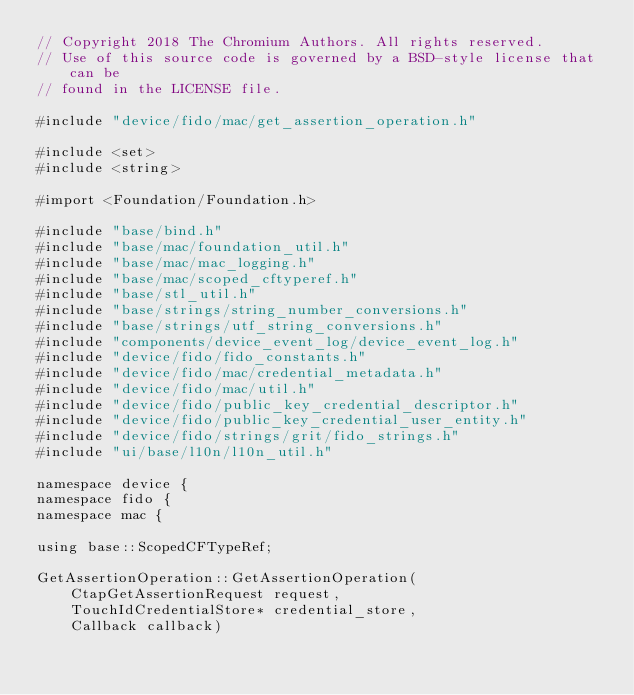Convert code to text. <code><loc_0><loc_0><loc_500><loc_500><_ObjectiveC_>// Copyright 2018 The Chromium Authors. All rights reserved.
// Use of this source code is governed by a BSD-style license that can be
// found in the LICENSE file.

#include "device/fido/mac/get_assertion_operation.h"

#include <set>
#include <string>

#import <Foundation/Foundation.h>

#include "base/bind.h"
#include "base/mac/foundation_util.h"
#include "base/mac/mac_logging.h"
#include "base/mac/scoped_cftyperef.h"
#include "base/stl_util.h"
#include "base/strings/string_number_conversions.h"
#include "base/strings/utf_string_conversions.h"
#include "components/device_event_log/device_event_log.h"
#include "device/fido/fido_constants.h"
#include "device/fido/mac/credential_metadata.h"
#include "device/fido/mac/util.h"
#include "device/fido/public_key_credential_descriptor.h"
#include "device/fido/public_key_credential_user_entity.h"
#include "device/fido/strings/grit/fido_strings.h"
#include "ui/base/l10n/l10n_util.h"

namespace device {
namespace fido {
namespace mac {

using base::ScopedCFTypeRef;

GetAssertionOperation::GetAssertionOperation(
    CtapGetAssertionRequest request,
    TouchIdCredentialStore* credential_store,
    Callback callback)</code> 